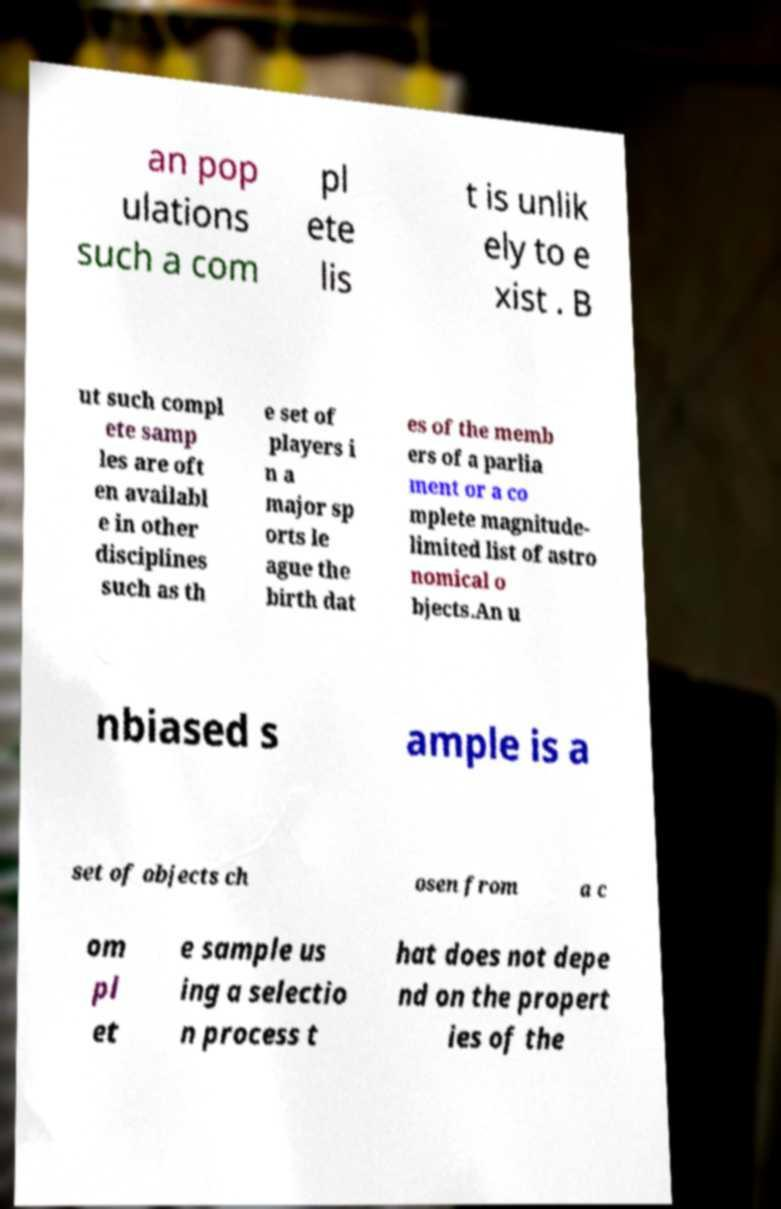Could you extract and type out the text from this image? an pop ulations such a com pl ete lis t is unlik ely to e xist . B ut such compl ete samp les are oft en availabl e in other disciplines such as th e set of players i n a major sp orts le ague the birth dat es of the memb ers of a parlia ment or a co mplete magnitude- limited list of astro nomical o bjects.An u nbiased s ample is a set of objects ch osen from a c om pl et e sample us ing a selectio n process t hat does not depe nd on the propert ies of the 